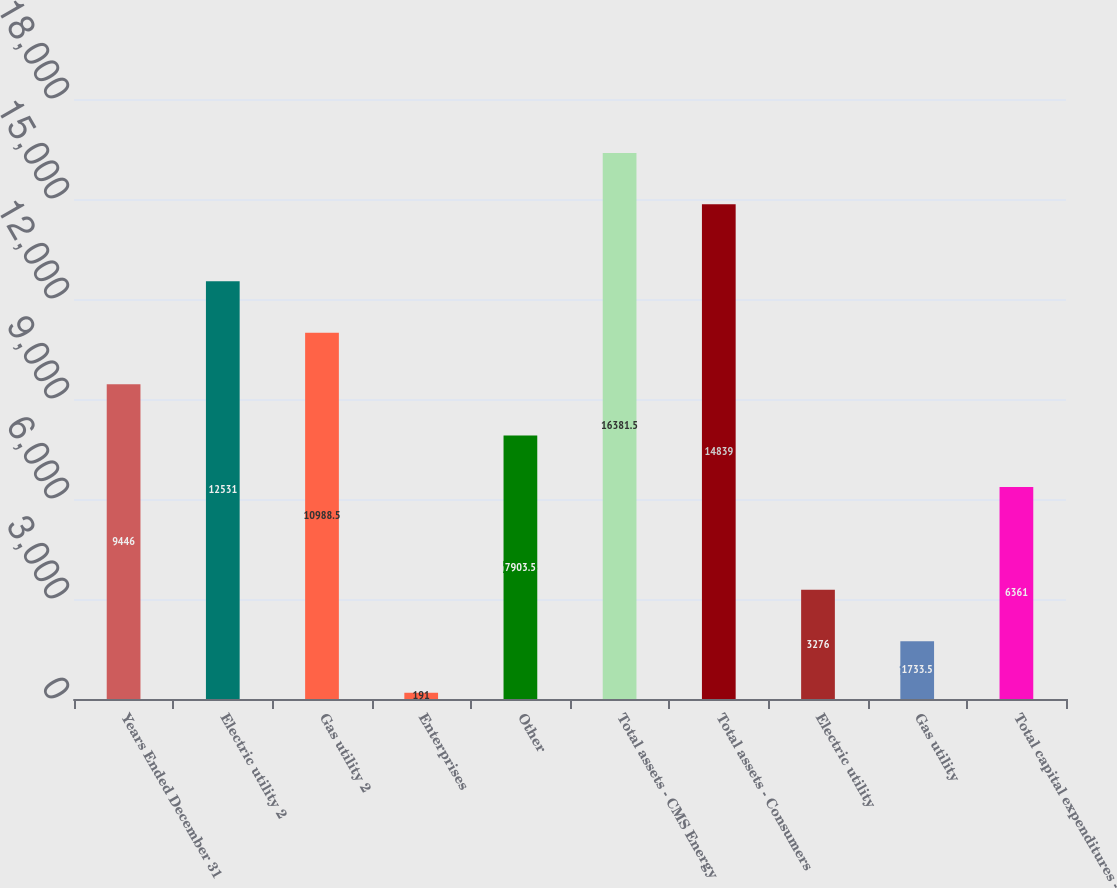Convert chart. <chart><loc_0><loc_0><loc_500><loc_500><bar_chart><fcel>Years Ended December 31<fcel>Electric utility 2<fcel>Gas utility 2<fcel>Enterprises<fcel>Other<fcel>Total assets - CMS Energy<fcel>Total assets - Consumers<fcel>Electric utility<fcel>Gas utility<fcel>Total capital expenditures -<nl><fcel>9446<fcel>12531<fcel>10988.5<fcel>191<fcel>7903.5<fcel>16381.5<fcel>14839<fcel>3276<fcel>1733.5<fcel>6361<nl></chart> 